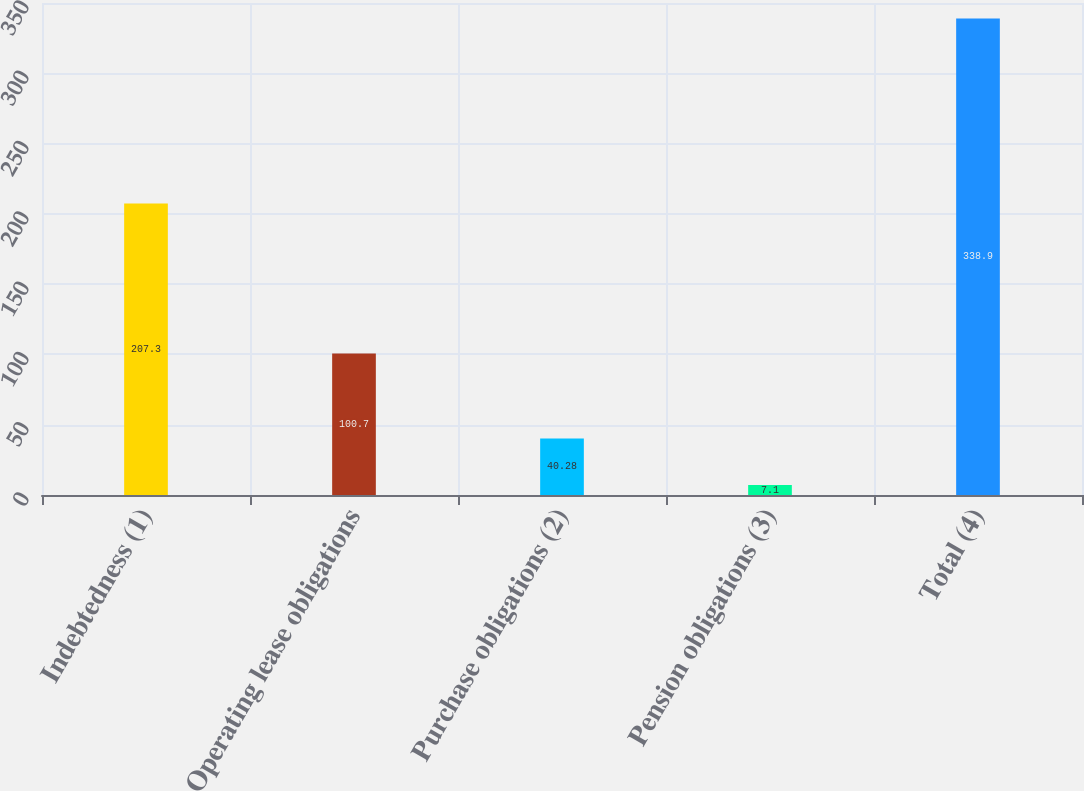Convert chart to OTSL. <chart><loc_0><loc_0><loc_500><loc_500><bar_chart><fcel>Indebtedness (1)<fcel>Operating lease obligations<fcel>Purchase obligations (2)<fcel>Pension obligations (3)<fcel>Total (4)<nl><fcel>207.3<fcel>100.7<fcel>40.28<fcel>7.1<fcel>338.9<nl></chart> 